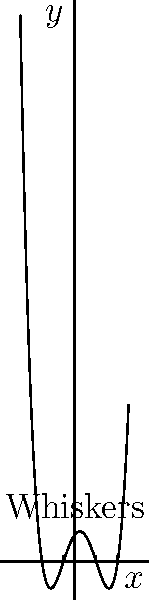In the library's cat-themed math section, you come across a book with a peculiar polynomial graph. The graph resembles a cat's face, where the whiskers are represented by the polynomial's roots crossing the x-axis. How many roots does this polynomial have, based on the number of "whiskers" crossing the x-axis? To determine the number of roots of the polynomial, we need to count the number of times the graph crosses the x-axis. This is equivalent to counting the number of "whiskers" in our cat-themed representation.

Let's analyze the graph step-by-step:

1. The graph is a continuous curve representing a polynomial function.
2. We can see that the curve crosses the x-axis at four distinct points.
3. These crossing points are located at approximately $x = -3$, $x = -1$, $x = 2$, and $x = 4$.
4. Each of these crossing points represents a root of the polynomial.
5. In the context of our cat-themed graph, each crossing point can be thought of as a "whisker" extending from the x-axis.

Therefore, we can conclude that the polynomial has 4 roots, as there are 4 "whiskers" crossing the x-axis.

This graph likely represents a 4th-degree polynomial (quartic function) since it has 4 roots. The general form of such a polynomial would be:

$f(x) = a(x-r_1)(x-r_2)(x-r_3)(x-r_4)$

where $a$ is a non-zero constant and $r_1$, $r_2$, $r_3$, and $r_4$ are the roots of the polynomial.
Answer: 4 roots 